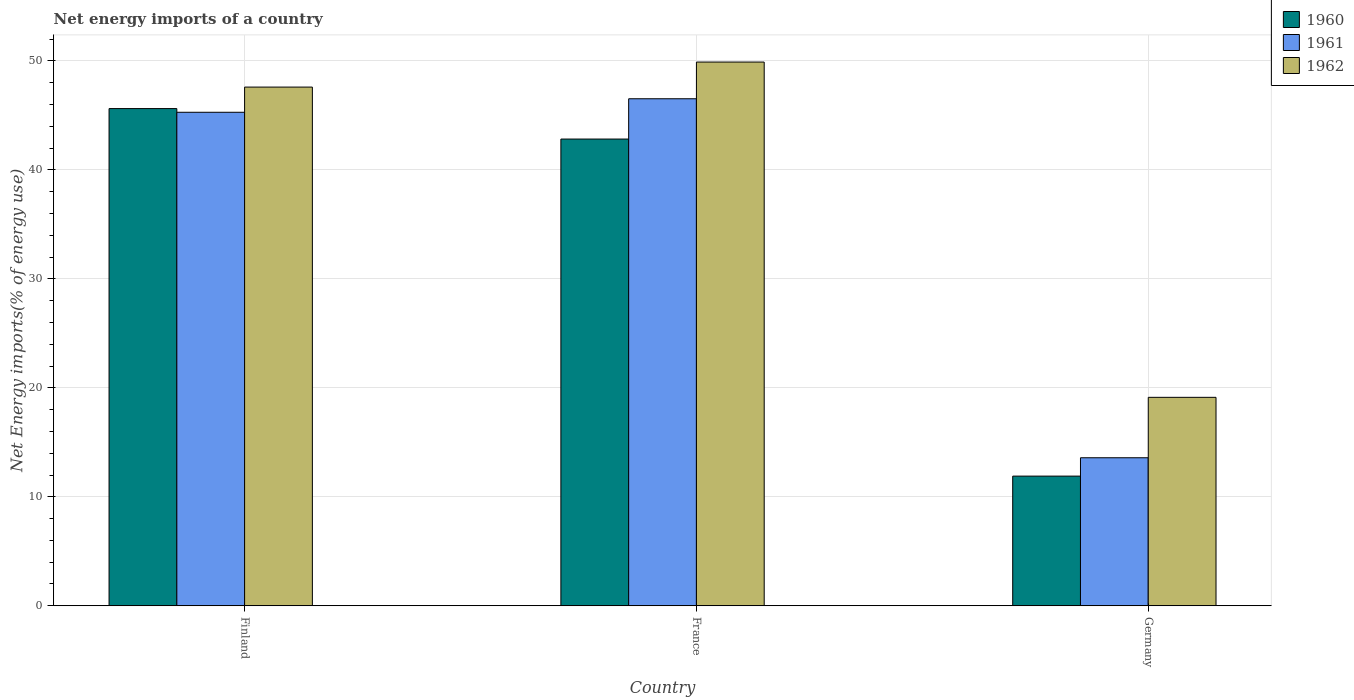Are the number of bars per tick equal to the number of legend labels?
Ensure brevity in your answer.  Yes. How many bars are there on the 3rd tick from the left?
Offer a very short reply. 3. In how many cases, is the number of bars for a given country not equal to the number of legend labels?
Offer a very short reply. 0. What is the net energy imports in 1962 in France?
Offer a terse response. 49.89. Across all countries, what is the maximum net energy imports in 1961?
Keep it short and to the point. 46.52. Across all countries, what is the minimum net energy imports in 1962?
Provide a short and direct response. 19.13. In which country was the net energy imports in 1962 minimum?
Provide a short and direct response. Germany. What is the total net energy imports in 1961 in the graph?
Give a very brief answer. 105.38. What is the difference between the net energy imports in 1962 in Finland and that in Germany?
Give a very brief answer. 28.47. What is the difference between the net energy imports in 1962 in Germany and the net energy imports in 1960 in Finland?
Make the answer very short. -26.49. What is the average net energy imports in 1962 per country?
Ensure brevity in your answer.  38.87. What is the difference between the net energy imports of/in 1962 and net energy imports of/in 1961 in France?
Provide a short and direct response. 3.37. What is the ratio of the net energy imports in 1961 in Finland to that in Germany?
Your answer should be very brief. 3.33. What is the difference between the highest and the second highest net energy imports in 1961?
Offer a terse response. -31.7. What is the difference between the highest and the lowest net energy imports in 1961?
Provide a succinct answer. 32.94. What does the 1st bar from the left in Germany represents?
Your response must be concise. 1960. What does the 2nd bar from the right in France represents?
Offer a very short reply. 1961. Is it the case that in every country, the sum of the net energy imports in 1960 and net energy imports in 1962 is greater than the net energy imports in 1961?
Your answer should be very brief. Yes. Are all the bars in the graph horizontal?
Provide a succinct answer. No. Where does the legend appear in the graph?
Ensure brevity in your answer.  Top right. How are the legend labels stacked?
Ensure brevity in your answer.  Vertical. What is the title of the graph?
Offer a terse response. Net energy imports of a country. What is the label or title of the Y-axis?
Your response must be concise. Net Energy imports(% of energy use). What is the Net Energy imports(% of energy use) of 1960 in Finland?
Your answer should be very brief. 45.62. What is the Net Energy imports(% of energy use) in 1961 in Finland?
Offer a terse response. 45.28. What is the Net Energy imports(% of energy use) of 1962 in Finland?
Your answer should be very brief. 47.59. What is the Net Energy imports(% of energy use) of 1960 in France?
Your answer should be compact. 42.82. What is the Net Energy imports(% of energy use) of 1961 in France?
Provide a short and direct response. 46.52. What is the Net Energy imports(% of energy use) of 1962 in France?
Your answer should be very brief. 49.89. What is the Net Energy imports(% of energy use) of 1960 in Germany?
Offer a terse response. 11.9. What is the Net Energy imports(% of energy use) in 1961 in Germany?
Your response must be concise. 13.58. What is the Net Energy imports(% of energy use) in 1962 in Germany?
Make the answer very short. 19.13. Across all countries, what is the maximum Net Energy imports(% of energy use) in 1960?
Offer a terse response. 45.62. Across all countries, what is the maximum Net Energy imports(% of energy use) of 1961?
Your response must be concise. 46.52. Across all countries, what is the maximum Net Energy imports(% of energy use) in 1962?
Keep it short and to the point. 49.89. Across all countries, what is the minimum Net Energy imports(% of energy use) of 1960?
Ensure brevity in your answer.  11.9. Across all countries, what is the minimum Net Energy imports(% of energy use) in 1961?
Give a very brief answer. 13.58. Across all countries, what is the minimum Net Energy imports(% of energy use) in 1962?
Give a very brief answer. 19.13. What is the total Net Energy imports(% of energy use) of 1960 in the graph?
Give a very brief answer. 100.34. What is the total Net Energy imports(% of energy use) in 1961 in the graph?
Keep it short and to the point. 105.38. What is the total Net Energy imports(% of energy use) in 1962 in the graph?
Keep it short and to the point. 116.61. What is the difference between the Net Energy imports(% of energy use) in 1960 in Finland and that in France?
Your answer should be compact. 2.8. What is the difference between the Net Energy imports(% of energy use) in 1961 in Finland and that in France?
Give a very brief answer. -1.24. What is the difference between the Net Energy imports(% of energy use) in 1962 in Finland and that in France?
Make the answer very short. -2.3. What is the difference between the Net Energy imports(% of energy use) of 1960 in Finland and that in Germany?
Offer a terse response. 33.72. What is the difference between the Net Energy imports(% of energy use) of 1961 in Finland and that in Germany?
Provide a short and direct response. 31.7. What is the difference between the Net Energy imports(% of energy use) of 1962 in Finland and that in Germany?
Offer a very short reply. 28.47. What is the difference between the Net Energy imports(% of energy use) of 1960 in France and that in Germany?
Offer a terse response. 30.93. What is the difference between the Net Energy imports(% of energy use) of 1961 in France and that in Germany?
Your answer should be very brief. 32.94. What is the difference between the Net Energy imports(% of energy use) in 1962 in France and that in Germany?
Give a very brief answer. 30.76. What is the difference between the Net Energy imports(% of energy use) of 1960 in Finland and the Net Energy imports(% of energy use) of 1961 in France?
Your response must be concise. -0.9. What is the difference between the Net Energy imports(% of energy use) of 1960 in Finland and the Net Energy imports(% of energy use) of 1962 in France?
Provide a succinct answer. -4.27. What is the difference between the Net Energy imports(% of energy use) of 1961 in Finland and the Net Energy imports(% of energy use) of 1962 in France?
Your answer should be very brief. -4.61. What is the difference between the Net Energy imports(% of energy use) of 1960 in Finland and the Net Energy imports(% of energy use) of 1961 in Germany?
Give a very brief answer. 32.04. What is the difference between the Net Energy imports(% of energy use) of 1960 in Finland and the Net Energy imports(% of energy use) of 1962 in Germany?
Your response must be concise. 26.49. What is the difference between the Net Energy imports(% of energy use) in 1961 in Finland and the Net Energy imports(% of energy use) in 1962 in Germany?
Offer a terse response. 26.15. What is the difference between the Net Energy imports(% of energy use) in 1960 in France and the Net Energy imports(% of energy use) in 1961 in Germany?
Ensure brevity in your answer.  29.24. What is the difference between the Net Energy imports(% of energy use) in 1960 in France and the Net Energy imports(% of energy use) in 1962 in Germany?
Your response must be concise. 23.7. What is the difference between the Net Energy imports(% of energy use) in 1961 in France and the Net Energy imports(% of energy use) in 1962 in Germany?
Ensure brevity in your answer.  27.39. What is the average Net Energy imports(% of energy use) of 1960 per country?
Ensure brevity in your answer.  33.45. What is the average Net Energy imports(% of energy use) of 1961 per country?
Your response must be concise. 35.13. What is the average Net Energy imports(% of energy use) in 1962 per country?
Offer a very short reply. 38.87. What is the difference between the Net Energy imports(% of energy use) in 1960 and Net Energy imports(% of energy use) in 1961 in Finland?
Give a very brief answer. 0.34. What is the difference between the Net Energy imports(% of energy use) of 1960 and Net Energy imports(% of energy use) of 1962 in Finland?
Give a very brief answer. -1.97. What is the difference between the Net Energy imports(% of energy use) in 1961 and Net Energy imports(% of energy use) in 1962 in Finland?
Give a very brief answer. -2.31. What is the difference between the Net Energy imports(% of energy use) of 1960 and Net Energy imports(% of energy use) of 1961 in France?
Your answer should be very brief. -3.7. What is the difference between the Net Energy imports(% of energy use) of 1960 and Net Energy imports(% of energy use) of 1962 in France?
Ensure brevity in your answer.  -7.06. What is the difference between the Net Energy imports(% of energy use) of 1961 and Net Energy imports(% of energy use) of 1962 in France?
Offer a terse response. -3.37. What is the difference between the Net Energy imports(% of energy use) in 1960 and Net Energy imports(% of energy use) in 1961 in Germany?
Give a very brief answer. -1.68. What is the difference between the Net Energy imports(% of energy use) of 1960 and Net Energy imports(% of energy use) of 1962 in Germany?
Provide a succinct answer. -7.23. What is the difference between the Net Energy imports(% of energy use) in 1961 and Net Energy imports(% of energy use) in 1962 in Germany?
Offer a very short reply. -5.54. What is the ratio of the Net Energy imports(% of energy use) of 1960 in Finland to that in France?
Ensure brevity in your answer.  1.07. What is the ratio of the Net Energy imports(% of energy use) of 1961 in Finland to that in France?
Keep it short and to the point. 0.97. What is the ratio of the Net Energy imports(% of energy use) of 1962 in Finland to that in France?
Make the answer very short. 0.95. What is the ratio of the Net Energy imports(% of energy use) of 1960 in Finland to that in Germany?
Make the answer very short. 3.83. What is the ratio of the Net Energy imports(% of energy use) of 1961 in Finland to that in Germany?
Offer a very short reply. 3.33. What is the ratio of the Net Energy imports(% of energy use) of 1962 in Finland to that in Germany?
Provide a short and direct response. 2.49. What is the ratio of the Net Energy imports(% of energy use) in 1960 in France to that in Germany?
Ensure brevity in your answer.  3.6. What is the ratio of the Net Energy imports(% of energy use) in 1961 in France to that in Germany?
Ensure brevity in your answer.  3.43. What is the ratio of the Net Energy imports(% of energy use) of 1962 in France to that in Germany?
Keep it short and to the point. 2.61. What is the difference between the highest and the second highest Net Energy imports(% of energy use) in 1960?
Your answer should be compact. 2.8. What is the difference between the highest and the second highest Net Energy imports(% of energy use) of 1961?
Make the answer very short. 1.24. What is the difference between the highest and the second highest Net Energy imports(% of energy use) of 1962?
Ensure brevity in your answer.  2.3. What is the difference between the highest and the lowest Net Energy imports(% of energy use) in 1960?
Your answer should be compact. 33.72. What is the difference between the highest and the lowest Net Energy imports(% of energy use) of 1961?
Provide a short and direct response. 32.94. What is the difference between the highest and the lowest Net Energy imports(% of energy use) in 1962?
Keep it short and to the point. 30.76. 